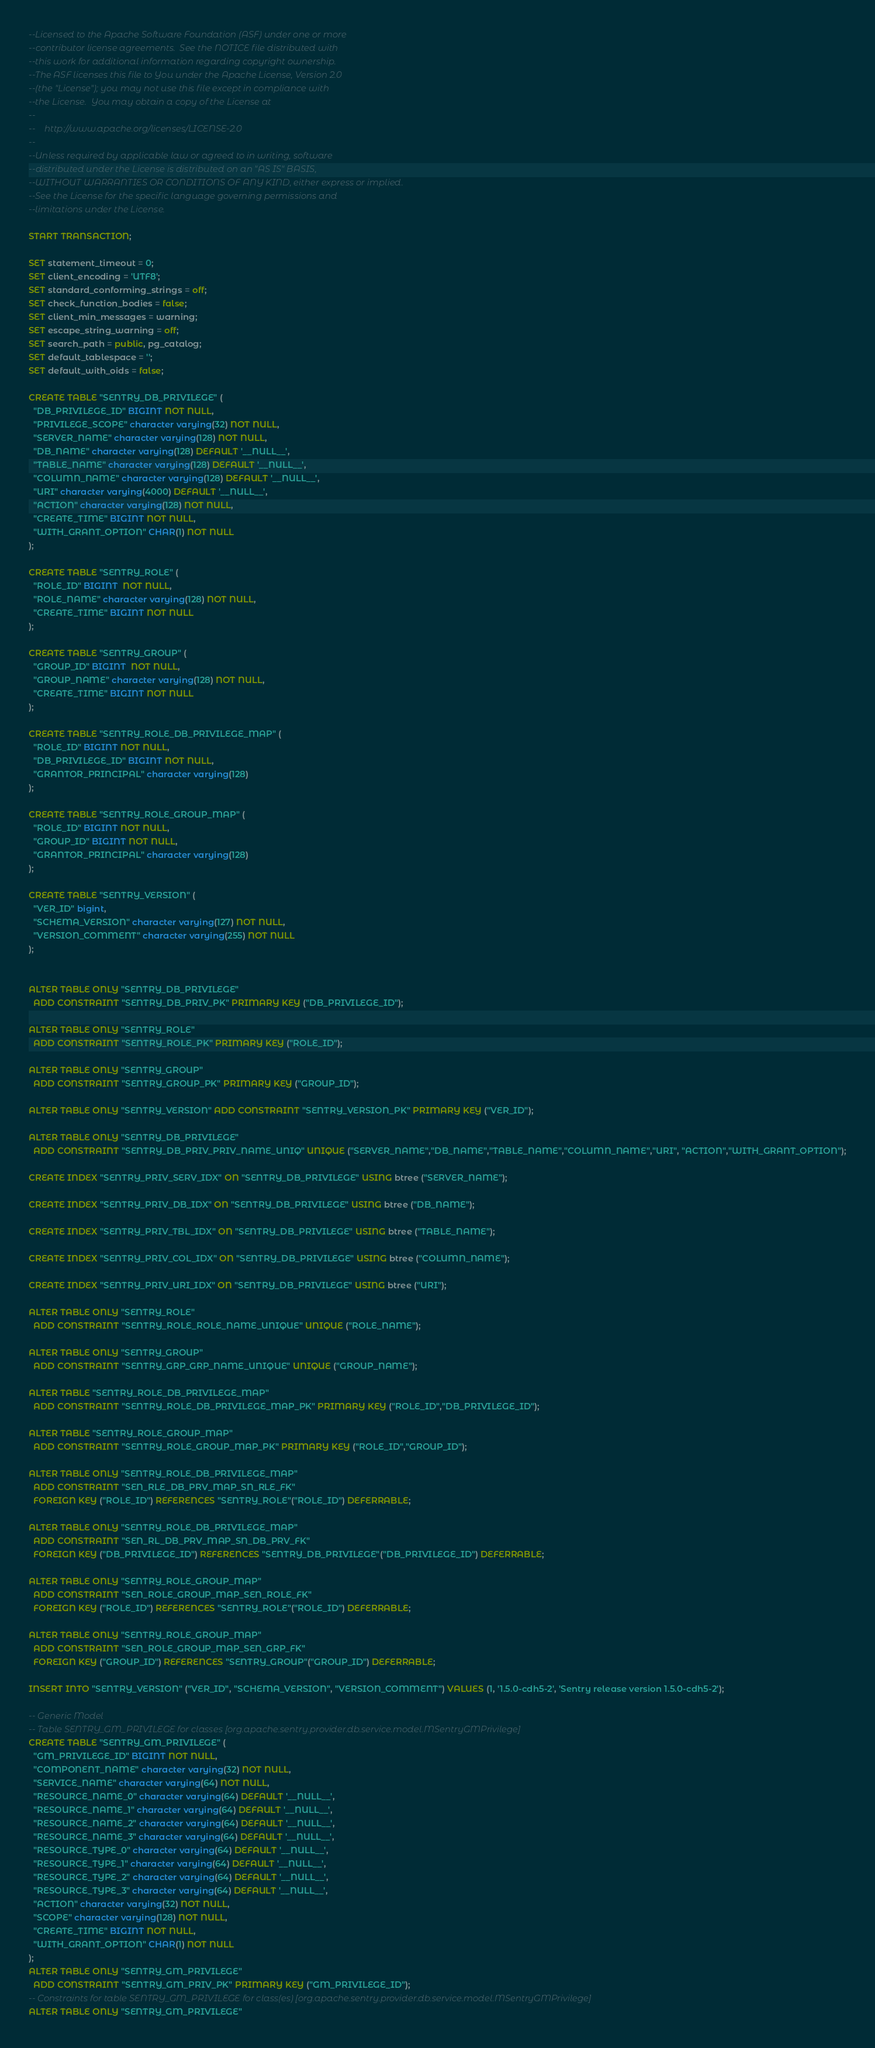Convert code to text. <code><loc_0><loc_0><loc_500><loc_500><_SQL_>--Licensed to the Apache Software Foundation (ASF) under one or more
--contributor license agreements.  See the NOTICE file distributed with
--this work for additional information regarding copyright ownership.
--The ASF licenses this file to You under the Apache License, Version 2.0
--(the "License"); you may not use this file except in compliance with
--the License.  You may obtain a copy of the License at
--
--    http://www.apache.org/licenses/LICENSE-2.0
--
--Unless required by applicable law or agreed to in writing, software
--distributed under the License is distributed on an "AS IS" BASIS,
--WITHOUT WARRANTIES OR CONDITIONS OF ANY KIND, either express or implied.
--See the License for the specific language governing permissions and
--limitations under the License.

START TRANSACTION;

SET statement_timeout = 0;
SET client_encoding = 'UTF8';
SET standard_conforming_strings = off;
SET check_function_bodies = false;
SET client_min_messages = warning;
SET escape_string_warning = off;
SET search_path = public, pg_catalog;
SET default_tablespace = '';
SET default_with_oids = false;

CREATE TABLE "SENTRY_DB_PRIVILEGE" (
  "DB_PRIVILEGE_ID" BIGINT NOT NULL,
  "PRIVILEGE_SCOPE" character varying(32) NOT NULL,
  "SERVER_NAME" character varying(128) NOT NULL,
  "DB_NAME" character varying(128) DEFAULT '__NULL__',
  "TABLE_NAME" character varying(128) DEFAULT '__NULL__',
  "COLUMN_NAME" character varying(128) DEFAULT '__NULL__',
  "URI" character varying(4000) DEFAULT '__NULL__',
  "ACTION" character varying(128) NOT NULL,
  "CREATE_TIME" BIGINT NOT NULL,
  "WITH_GRANT_OPTION" CHAR(1) NOT NULL
);

CREATE TABLE "SENTRY_ROLE" (
  "ROLE_ID" BIGINT  NOT NULL,
  "ROLE_NAME" character varying(128) NOT NULL,
  "CREATE_TIME" BIGINT NOT NULL
);

CREATE TABLE "SENTRY_GROUP" (
  "GROUP_ID" BIGINT  NOT NULL,
  "GROUP_NAME" character varying(128) NOT NULL,
  "CREATE_TIME" BIGINT NOT NULL
);

CREATE TABLE "SENTRY_ROLE_DB_PRIVILEGE_MAP" (
  "ROLE_ID" BIGINT NOT NULL,
  "DB_PRIVILEGE_ID" BIGINT NOT NULL,
  "GRANTOR_PRINCIPAL" character varying(128)
);

CREATE TABLE "SENTRY_ROLE_GROUP_MAP" (
  "ROLE_ID" BIGINT NOT NULL,
  "GROUP_ID" BIGINT NOT NULL,
  "GRANTOR_PRINCIPAL" character varying(128)
);

CREATE TABLE "SENTRY_VERSION" (
  "VER_ID" bigint,
  "SCHEMA_VERSION" character varying(127) NOT NULL,
  "VERSION_COMMENT" character varying(255) NOT NULL
);


ALTER TABLE ONLY "SENTRY_DB_PRIVILEGE"
  ADD CONSTRAINT "SENTRY_DB_PRIV_PK" PRIMARY KEY ("DB_PRIVILEGE_ID");

ALTER TABLE ONLY "SENTRY_ROLE"
  ADD CONSTRAINT "SENTRY_ROLE_PK" PRIMARY KEY ("ROLE_ID");

ALTER TABLE ONLY "SENTRY_GROUP"
  ADD CONSTRAINT "SENTRY_GROUP_PK" PRIMARY KEY ("GROUP_ID");

ALTER TABLE ONLY "SENTRY_VERSION" ADD CONSTRAINT "SENTRY_VERSION_PK" PRIMARY KEY ("VER_ID");

ALTER TABLE ONLY "SENTRY_DB_PRIVILEGE"
  ADD CONSTRAINT "SENTRY_DB_PRIV_PRIV_NAME_UNIQ" UNIQUE ("SERVER_NAME","DB_NAME","TABLE_NAME","COLUMN_NAME","URI", "ACTION","WITH_GRANT_OPTION");

CREATE INDEX "SENTRY_PRIV_SERV_IDX" ON "SENTRY_DB_PRIVILEGE" USING btree ("SERVER_NAME");

CREATE INDEX "SENTRY_PRIV_DB_IDX" ON "SENTRY_DB_PRIVILEGE" USING btree ("DB_NAME");

CREATE INDEX "SENTRY_PRIV_TBL_IDX" ON "SENTRY_DB_PRIVILEGE" USING btree ("TABLE_NAME");

CREATE INDEX "SENTRY_PRIV_COL_IDX" ON "SENTRY_DB_PRIVILEGE" USING btree ("COLUMN_NAME");

CREATE INDEX "SENTRY_PRIV_URI_IDX" ON "SENTRY_DB_PRIVILEGE" USING btree ("URI");

ALTER TABLE ONLY "SENTRY_ROLE"
  ADD CONSTRAINT "SENTRY_ROLE_ROLE_NAME_UNIQUE" UNIQUE ("ROLE_NAME");

ALTER TABLE ONLY "SENTRY_GROUP"
  ADD CONSTRAINT "SENTRY_GRP_GRP_NAME_UNIQUE" UNIQUE ("GROUP_NAME");

ALTER TABLE "SENTRY_ROLE_DB_PRIVILEGE_MAP"
  ADD CONSTRAINT "SENTRY_ROLE_DB_PRIVILEGE_MAP_PK" PRIMARY KEY ("ROLE_ID","DB_PRIVILEGE_ID");

ALTER TABLE "SENTRY_ROLE_GROUP_MAP"
  ADD CONSTRAINT "SENTRY_ROLE_GROUP_MAP_PK" PRIMARY KEY ("ROLE_ID","GROUP_ID");

ALTER TABLE ONLY "SENTRY_ROLE_DB_PRIVILEGE_MAP"
  ADD CONSTRAINT "SEN_RLE_DB_PRV_MAP_SN_RLE_FK"
  FOREIGN KEY ("ROLE_ID") REFERENCES "SENTRY_ROLE"("ROLE_ID") DEFERRABLE;

ALTER TABLE ONLY "SENTRY_ROLE_DB_PRIVILEGE_MAP"
  ADD CONSTRAINT "SEN_RL_DB_PRV_MAP_SN_DB_PRV_FK"
  FOREIGN KEY ("DB_PRIVILEGE_ID") REFERENCES "SENTRY_DB_PRIVILEGE"("DB_PRIVILEGE_ID") DEFERRABLE;

ALTER TABLE ONLY "SENTRY_ROLE_GROUP_MAP"
  ADD CONSTRAINT "SEN_ROLE_GROUP_MAP_SEN_ROLE_FK"
  FOREIGN KEY ("ROLE_ID") REFERENCES "SENTRY_ROLE"("ROLE_ID") DEFERRABLE;

ALTER TABLE ONLY "SENTRY_ROLE_GROUP_MAP"
  ADD CONSTRAINT "SEN_ROLE_GROUP_MAP_SEN_GRP_FK"
  FOREIGN KEY ("GROUP_ID") REFERENCES "SENTRY_GROUP"("GROUP_ID") DEFERRABLE;

INSERT INTO "SENTRY_VERSION" ("VER_ID", "SCHEMA_VERSION", "VERSION_COMMENT") VALUES (1, '1.5.0-cdh5-2', 'Sentry release version 1.5.0-cdh5-2');

-- Generic Model
-- Table SENTRY_GM_PRIVILEGE for classes [org.apache.sentry.provider.db.service.model.MSentryGMPrivilege]
CREATE TABLE "SENTRY_GM_PRIVILEGE" (
  "GM_PRIVILEGE_ID" BIGINT NOT NULL,
  "COMPONENT_NAME" character varying(32) NOT NULL,
  "SERVICE_NAME" character varying(64) NOT NULL,
  "RESOURCE_NAME_0" character varying(64) DEFAULT '__NULL__',
  "RESOURCE_NAME_1" character varying(64) DEFAULT '__NULL__',
  "RESOURCE_NAME_2" character varying(64) DEFAULT '__NULL__',
  "RESOURCE_NAME_3" character varying(64) DEFAULT '__NULL__',
  "RESOURCE_TYPE_0" character varying(64) DEFAULT '__NULL__',
  "RESOURCE_TYPE_1" character varying(64) DEFAULT '__NULL__',
  "RESOURCE_TYPE_2" character varying(64) DEFAULT '__NULL__',
  "RESOURCE_TYPE_3" character varying(64) DEFAULT '__NULL__',
  "ACTION" character varying(32) NOT NULL,
  "SCOPE" character varying(128) NOT NULL,
  "CREATE_TIME" BIGINT NOT NULL,
  "WITH_GRANT_OPTION" CHAR(1) NOT NULL
);
ALTER TABLE ONLY "SENTRY_GM_PRIVILEGE"
  ADD CONSTRAINT "SENTRY_GM_PRIV_PK" PRIMARY KEY ("GM_PRIVILEGE_ID");
-- Constraints for table SENTRY_GM_PRIVILEGE for class(es) [org.apache.sentry.provider.db.service.model.MSentryGMPrivilege]
ALTER TABLE ONLY "SENTRY_GM_PRIVILEGE"</code> 